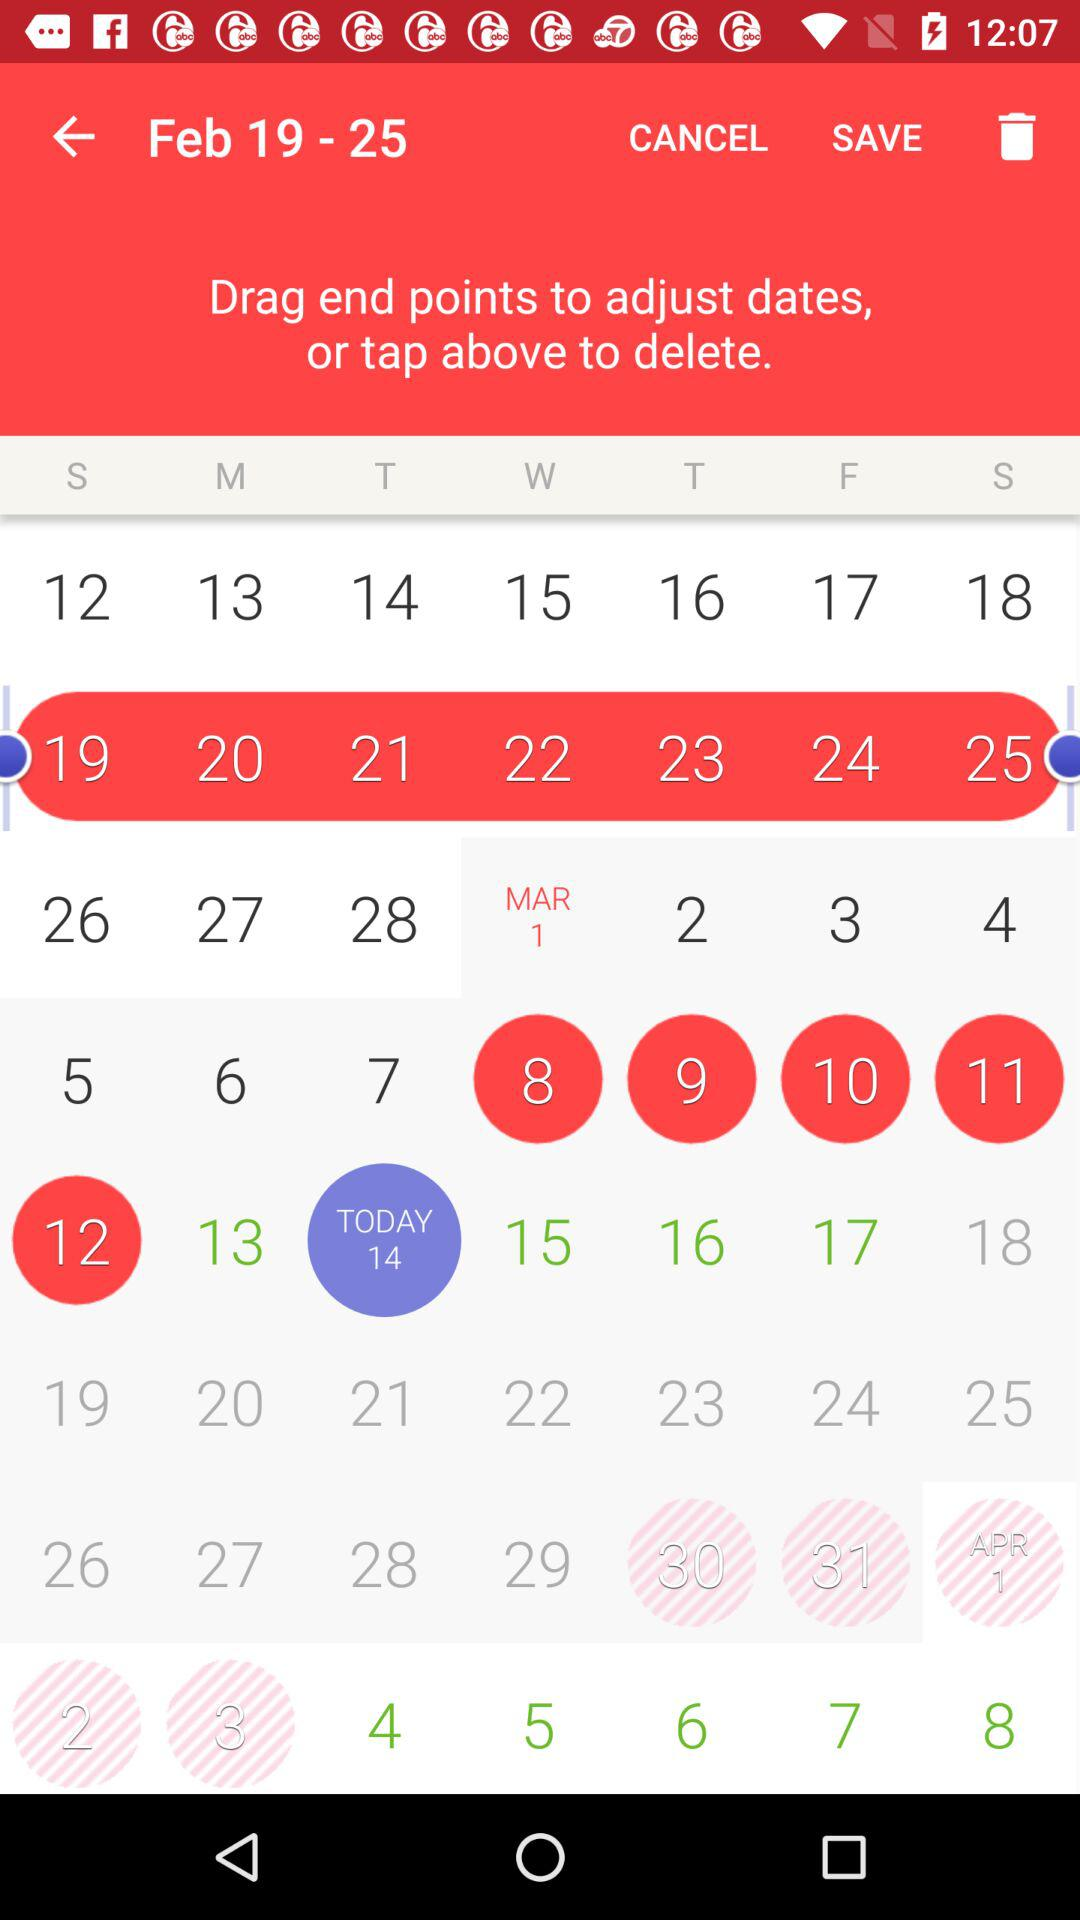What is the date today? The date is Tuesday, February 14. 